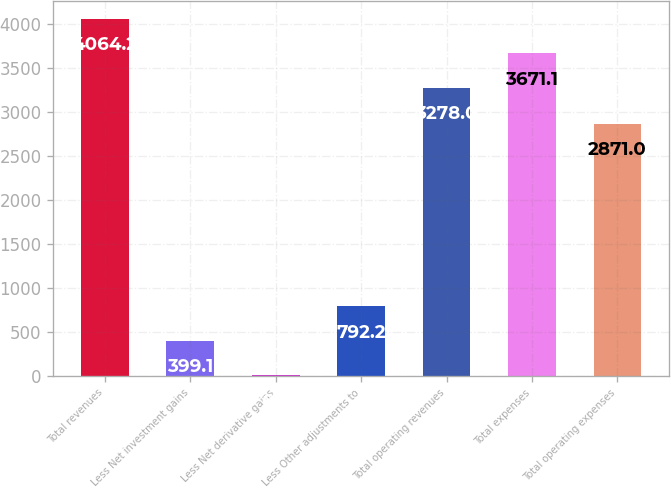Convert chart to OTSL. <chart><loc_0><loc_0><loc_500><loc_500><bar_chart><fcel>Total revenues<fcel>Less Net investment gains<fcel>Less Net derivative gains<fcel>Less Other adjustments to<fcel>Total operating revenues<fcel>Total expenses<fcel>Total operating expenses<nl><fcel>4064.2<fcel>399.1<fcel>6<fcel>792.2<fcel>3278<fcel>3671.1<fcel>2871<nl></chart> 